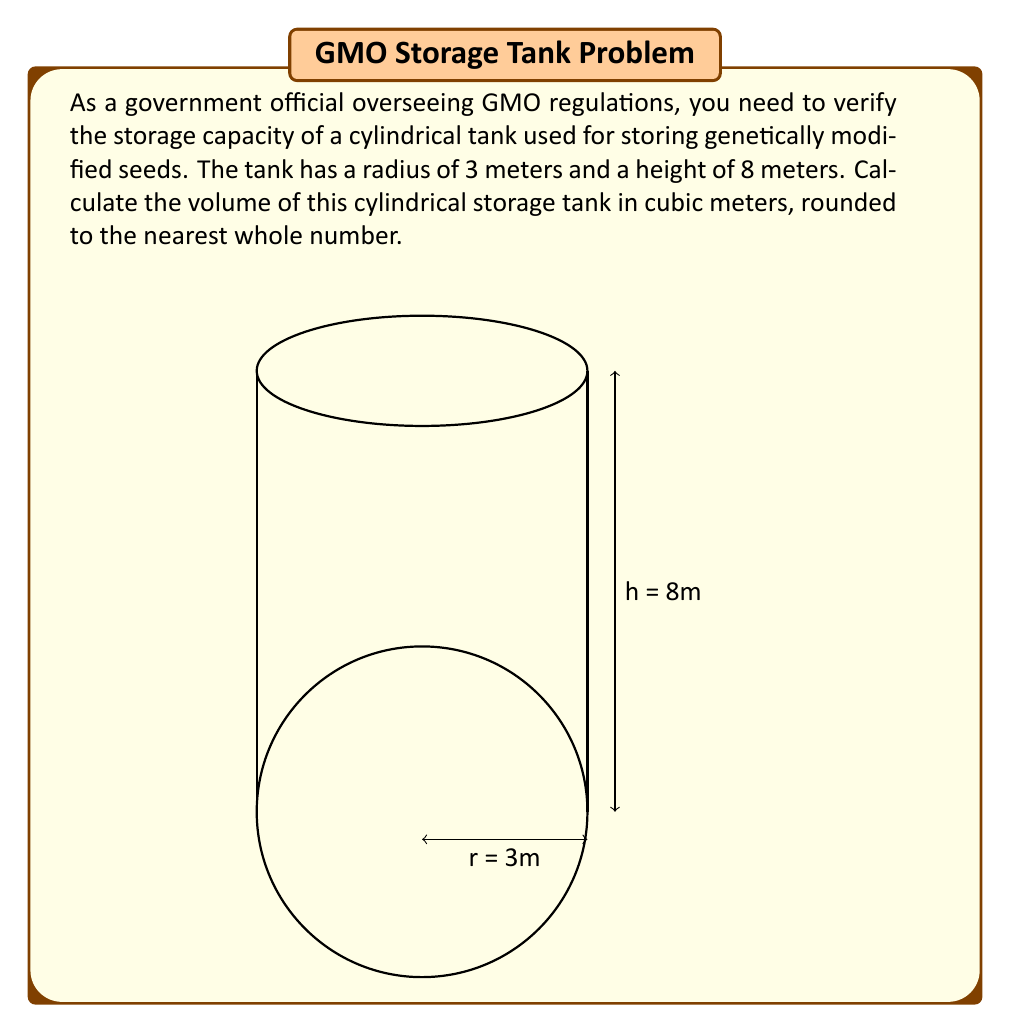Could you help me with this problem? To calculate the volume of a cylindrical tank, we use the formula:

$$V = \pi r^2 h$$

Where:
$V$ = volume
$r$ = radius of the base
$h$ = height of the cylinder

Given:
$r = 3$ meters
$h = 8$ meters

Let's substitute these values into the formula:

$$V = \pi (3\text{ m})^2 (8\text{ m})$$

Simplifying:
$$V = \pi (9\text{ m}^2) (8\text{ m})$$
$$V = 72\pi\text{ m}^3$$

Using $\pi \approx 3.14159$:

$$V \approx 72 \times 3.14159\text{ m}^3$$
$$V \approx 226.19448\text{ m}^3$$

Rounding to the nearest whole number:

$$V \approx 226\text{ m}^3$$

Therefore, the volume of the cylindrical storage tank for GMO seeds is approximately 226 cubic meters.
Answer: 226 m³ 